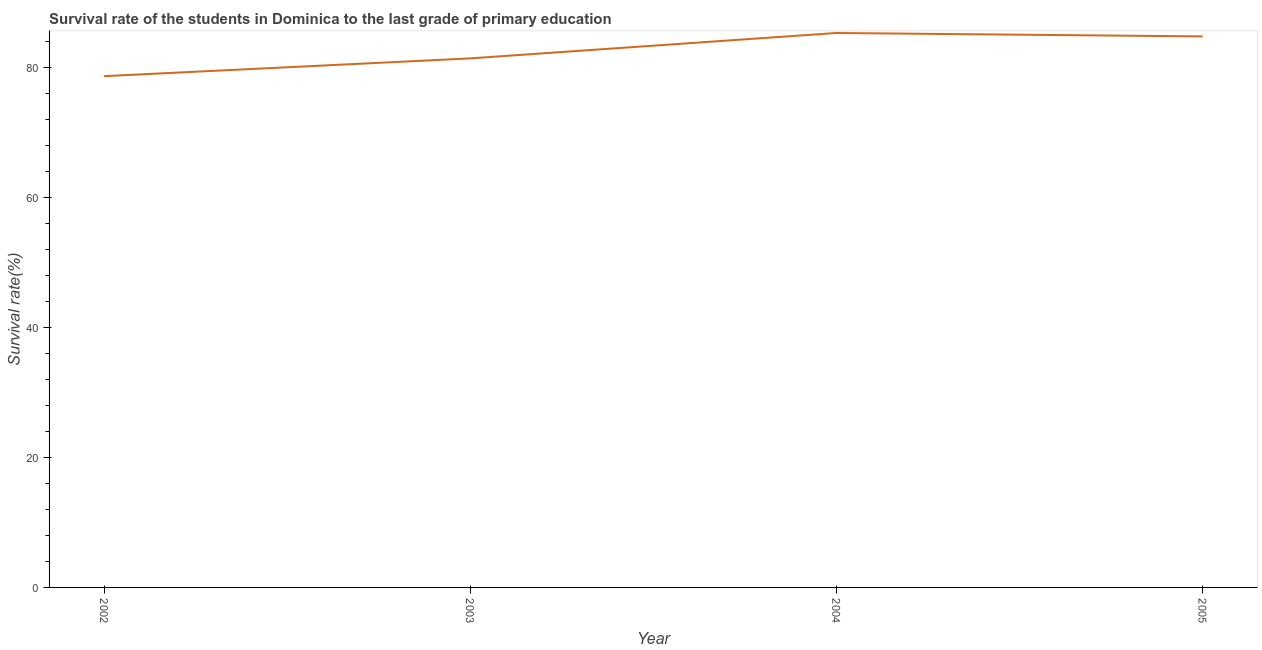What is the survival rate in primary education in 2002?
Ensure brevity in your answer.  78.68. Across all years, what is the maximum survival rate in primary education?
Your response must be concise. 85.32. Across all years, what is the minimum survival rate in primary education?
Your answer should be very brief. 78.68. In which year was the survival rate in primary education minimum?
Give a very brief answer. 2002. What is the sum of the survival rate in primary education?
Offer a terse response. 330.2. What is the difference between the survival rate in primary education in 2004 and 2005?
Provide a succinct answer. 0.53. What is the average survival rate in primary education per year?
Your answer should be very brief. 82.55. What is the median survival rate in primary education?
Provide a succinct answer. 83.1. Do a majority of the years between 2003 and 2005 (inclusive) have survival rate in primary education greater than 40 %?
Make the answer very short. Yes. What is the ratio of the survival rate in primary education in 2003 to that in 2004?
Your answer should be very brief. 0.95. Is the survival rate in primary education in 2003 less than that in 2005?
Your answer should be compact. Yes. Is the difference between the survival rate in primary education in 2002 and 2003 greater than the difference between any two years?
Provide a succinct answer. No. What is the difference between the highest and the second highest survival rate in primary education?
Your answer should be compact. 0.53. What is the difference between the highest and the lowest survival rate in primary education?
Offer a terse response. 6.64. In how many years, is the survival rate in primary education greater than the average survival rate in primary education taken over all years?
Your answer should be compact. 2. Does the survival rate in primary education monotonically increase over the years?
Your answer should be very brief. No. How many years are there in the graph?
Your answer should be very brief. 4. What is the title of the graph?
Offer a terse response. Survival rate of the students in Dominica to the last grade of primary education. What is the label or title of the Y-axis?
Provide a short and direct response. Survival rate(%). What is the Survival rate(%) in 2002?
Make the answer very short. 78.68. What is the Survival rate(%) in 2003?
Provide a succinct answer. 81.41. What is the Survival rate(%) of 2004?
Provide a short and direct response. 85.32. What is the Survival rate(%) of 2005?
Provide a short and direct response. 84.79. What is the difference between the Survival rate(%) in 2002 and 2003?
Provide a succinct answer. -2.74. What is the difference between the Survival rate(%) in 2002 and 2004?
Ensure brevity in your answer.  -6.64. What is the difference between the Survival rate(%) in 2002 and 2005?
Your response must be concise. -6.12. What is the difference between the Survival rate(%) in 2003 and 2004?
Provide a short and direct response. -3.91. What is the difference between the Survival rate(%) in 2003 and 2005?
Your answer should be compact. -3.38. What is the difference between the Survival rate(%) in 2004 and 2005?
Your answer should be very brief. 0.53. What is the ratio of the Survival rate(%) in 2002 to that in 2003?
Keep it short and to the point. 0.97. What is the ratio of the Survival rate(%) in 2002 to that in 2004?
Ensure brevity in your answer.  0.92. What is the ratio of the Survival rate(%) in 2002 to that in 2005?
Provide a succinct answer. 0.93. What is the ratio of the Survival rate(%) in 2003 to that in 2004?
Give a very brief answer. 0.95. What is the ratio of the Survival rate(%) in 2003 to that in 2005?
Provide a succinct answer. 0.96. 